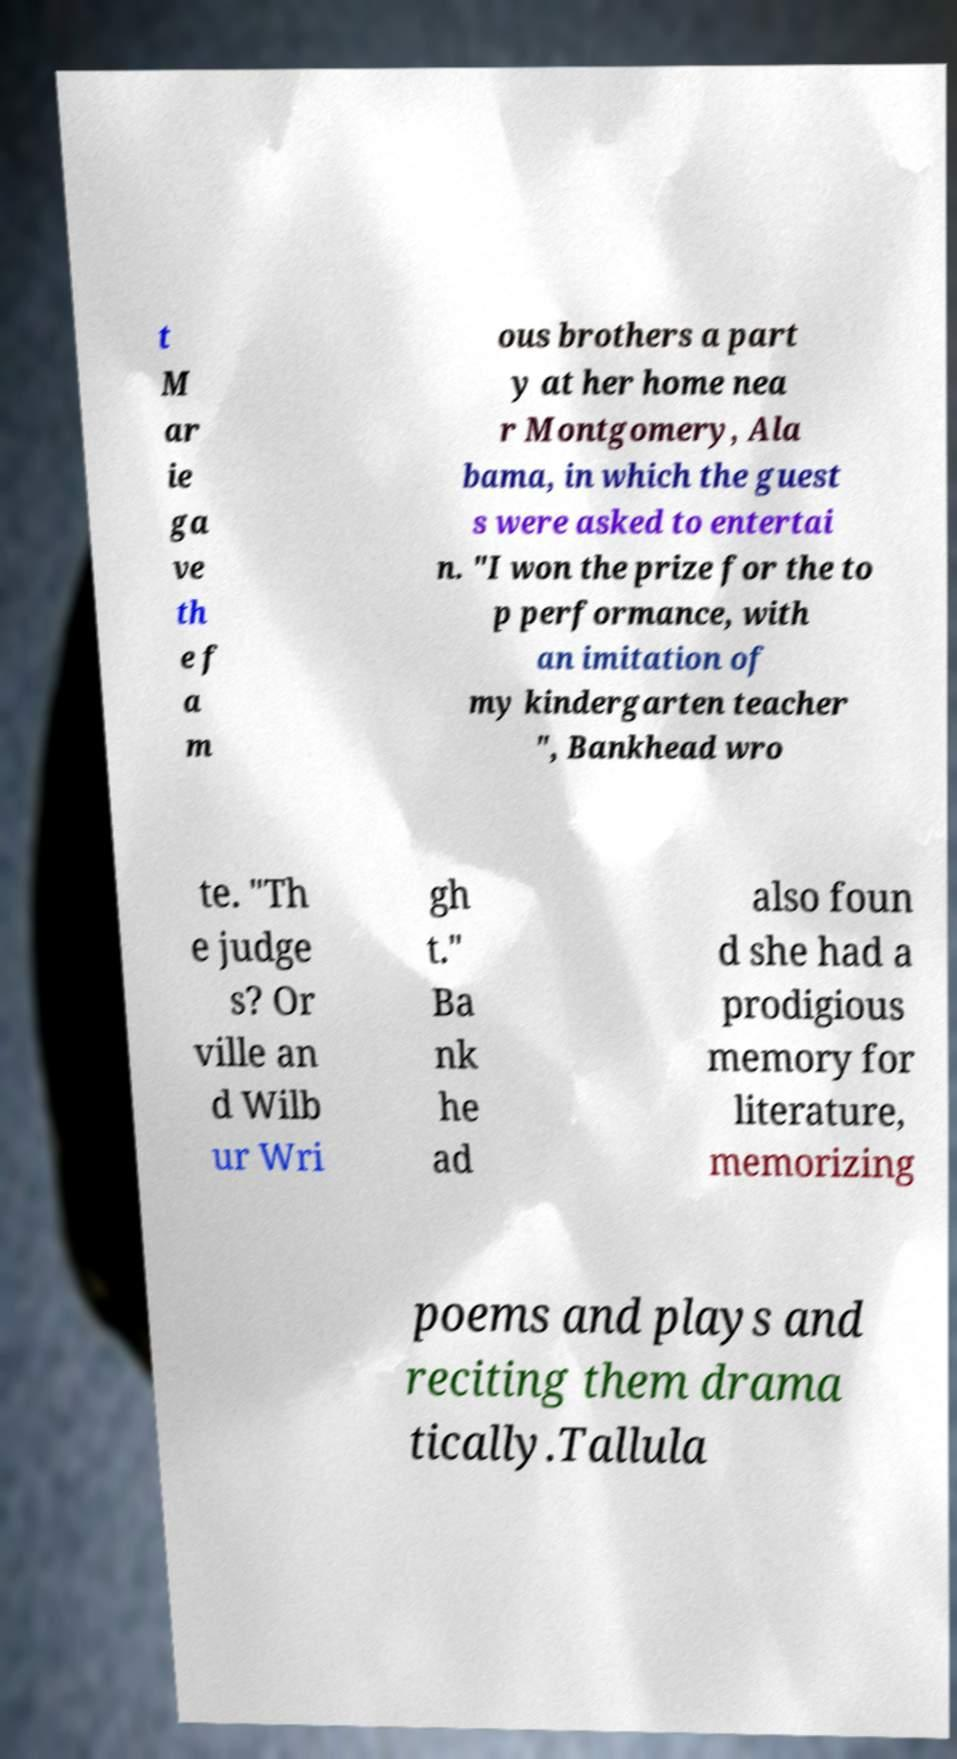Please identify and transcribe the text found in this image. t M ar ie ga ve th e f a m ous brothers a part y at her home nea r Montgomery, Ala bama, in which the guest s were asked to entertai n. "I won the prize for the to p performance, with an imitation of my kindergarten teacher ", Bankhead wro te. "Th e judge s? Or ville an d Wilb ur Wri gh t." Ba nk he ad also foun d she had a prodigious memory for literature, memorizing poems and plays and reciting them drama tically.Tallula 